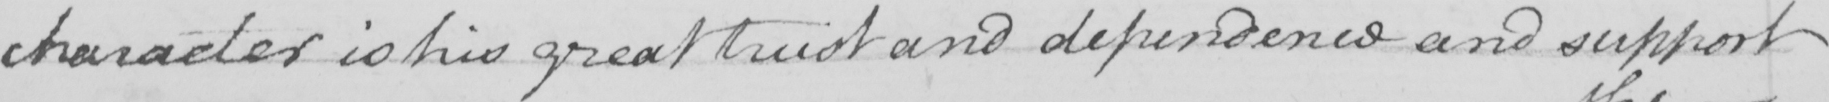What text is written in this handwritten line? character is his great trust and dependence and support 